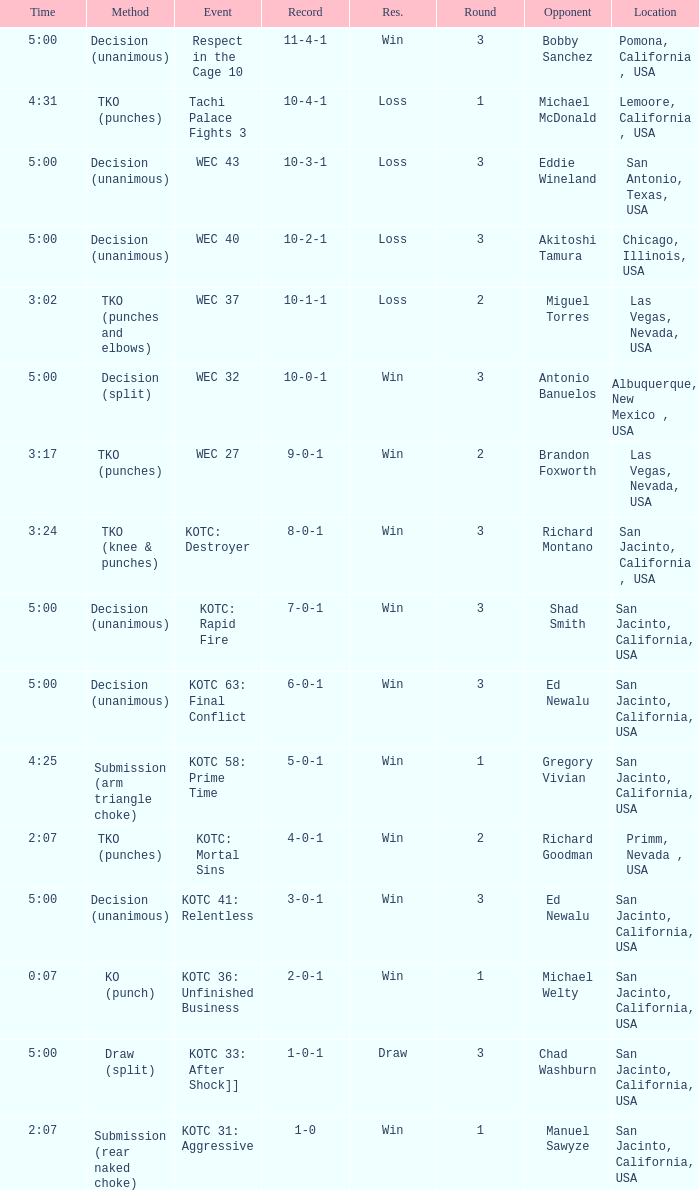What time did the even tachi palace fights 3 take place? 4:31. I'm looking to parse the entire table for insights. Could you assist me with that? {'header': ['Time', 'Method', 'Event', 'Record', 'Res.', 'Round', 'Opponent', 'Location'], 'rows': [['5:00', 'Decision (unanimous)', 'Respect in the Cage 10', '11-4-1', 'Win', '3', 'Bobby Sanchez', 'Pomona, California , USA'], ['4:31', 'TKO (punches)', 'Tachi Palace Fights 3', '10-4-1', 'Loss', '1', 'Michael McDonald', 'Lemoore, California , USA'], ['5:00', 'Decision (unanimous)', 'WEC 43', '10-3-1', 'Loss', '3', 'Eddie Wineland', 'San Antonio, Texas, USA'], ['5:00', 'Decision (unanimous)', 'WEC 40', '10-2-1', 'Loss', '3', 'Akitoshi Tamura', 'Chicago, Illinois, USA'], ['3:02', 'TKO (punches and elbows)', 'WEC 37', '10-1-1', 'Loss', '2', 'Miguel Torres', 'Las Vegas, Nevada, USA'], ['5:00', 'Decision (split)', 'WEC 32', '10-0-1', 'Win', '3', 'Antonio Banuelos', 'Albuquerque, New Mexico , USA'], ['3:17', 'TKO (punches)', 'WEC 27', '9-0-1', 'Win', '2', 'Brandon Foxworth', 'Las Vegas, Nevada, USA'], ['3:24', 'TKO (knee & punches)', 'KOTC: Destroyer', '8-0-1', 'Win', '3', 'Richard Montano', 'San Jacinto, California , USA'], ['5:00', 'Decision (unanimous)', 'KOTC: Rapid Fire', '7-0-1', 'Win', '3', 'Shad Smith', 'San Jacinto, California, USA'], ['5:00', 'Decision (unanimous)', 'KOTC 63: Final Conflict', '6-0-1', 'Win', '3', 'Ed Newalu', 'San Jacinto, California, USA'], ['4:25', 'Submission (arm triangle choke)', 'KOTC 58: Prime Time', '5-0-1', 'Win', '1', 'Gregory Vivian', 'San Jacinto, California, USA'], ['2:07', 'TKO (punches)', 'KOTC: Mortal Sins', '4-0-1', 'Win', '2', 'Richard Goodman', 'Primm, Nevada , USA'], ['5:00', 'Decision (unanimous)', 'KOTC 41: Relentless', '3-0-1', 'Win', '3', 'Ed Newalu', 'San Jacinto, California, USA'], ['0:07', 'KO (punch)', 'KOTC 36: Unfinished Business', '2-0-1', 'Win', '1', 'Michael Welty', 'San Jacinto, California, USA'], ['5:00', 'Draw (split)', 'KOTC 33: After Shock]]', '1-0-1', 'Draw', '3', 'Chad Washburn', 'San Jacinto, California, USA'], ['2:07', 'Submission (rear naked choke)', 'KOTC 31: Aggressive', '1-0', 'Win', '1', 'Manuel Sawyze', 'San Jacinto, California, USA']]} 